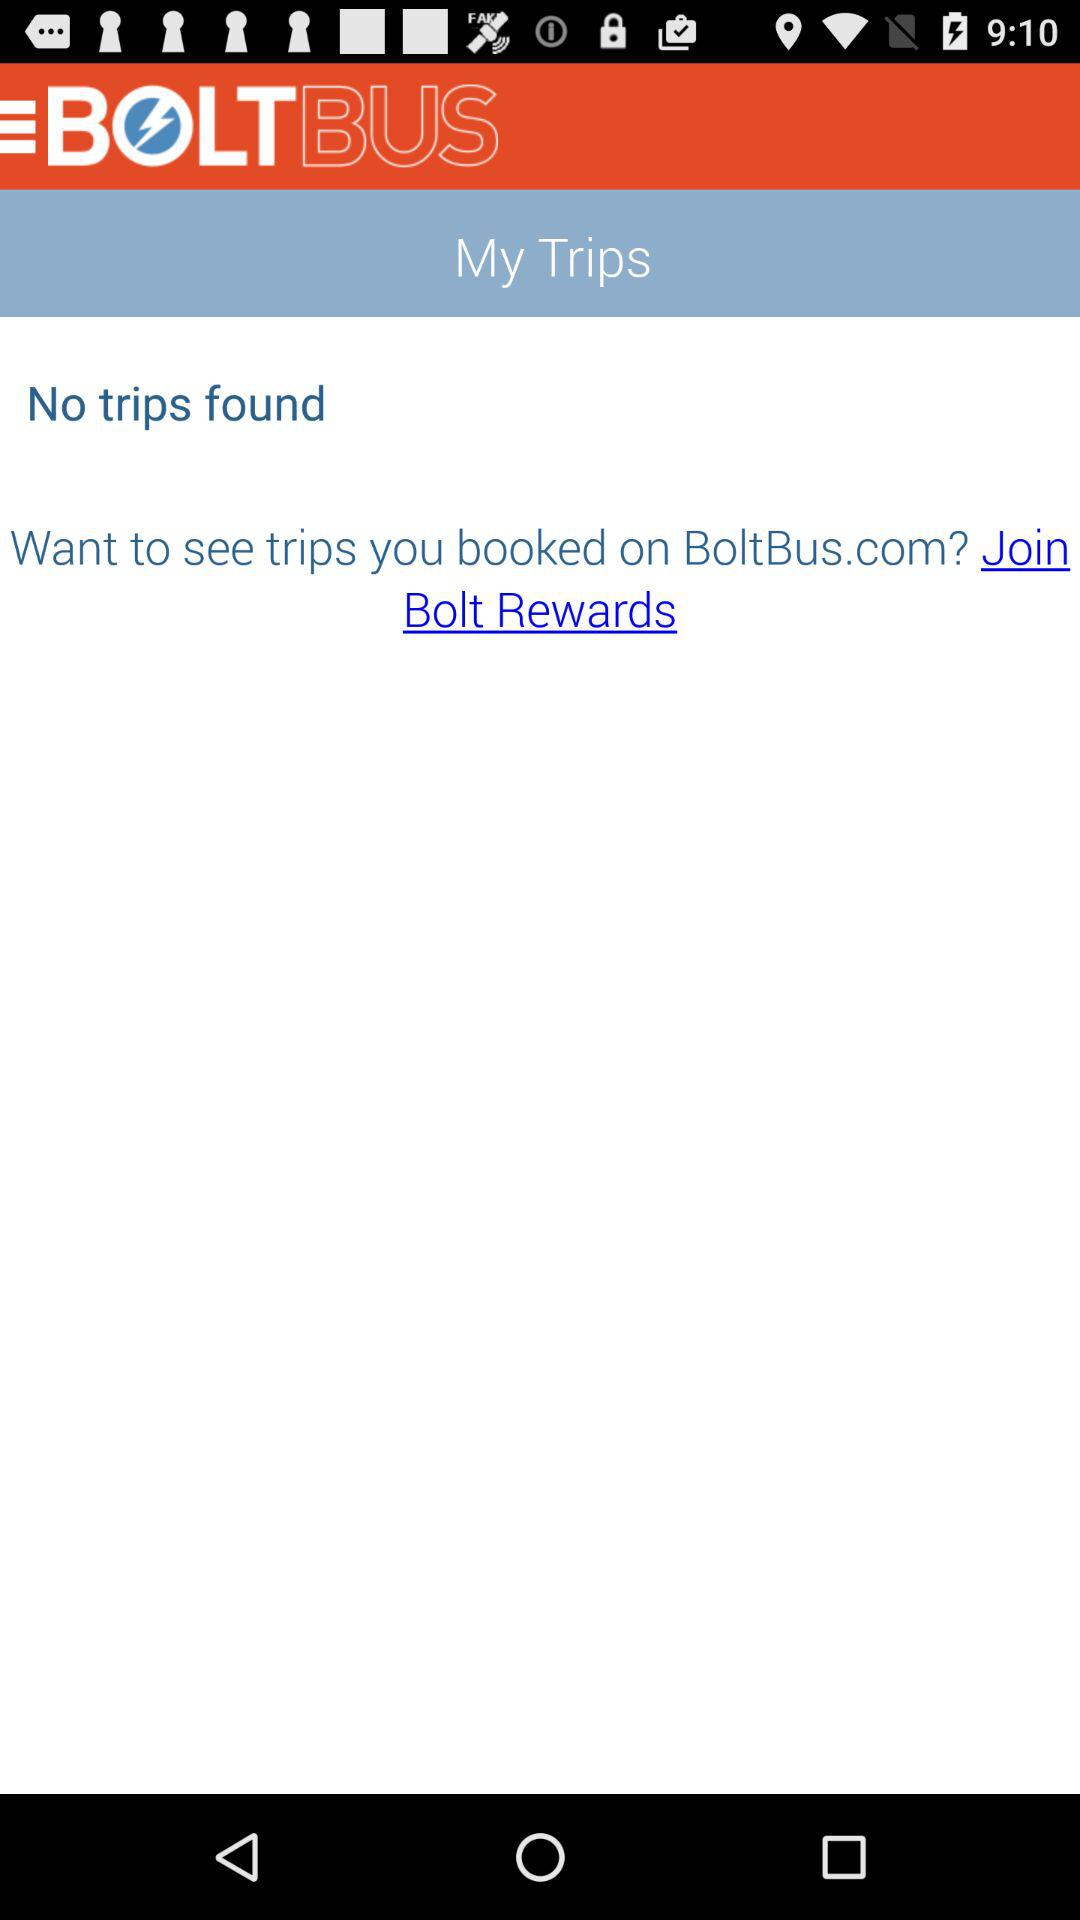How can booked trips on BoltBus.com be seen? Booked trips on BoltBus.com can be seen by joining Bolt Rewards. 